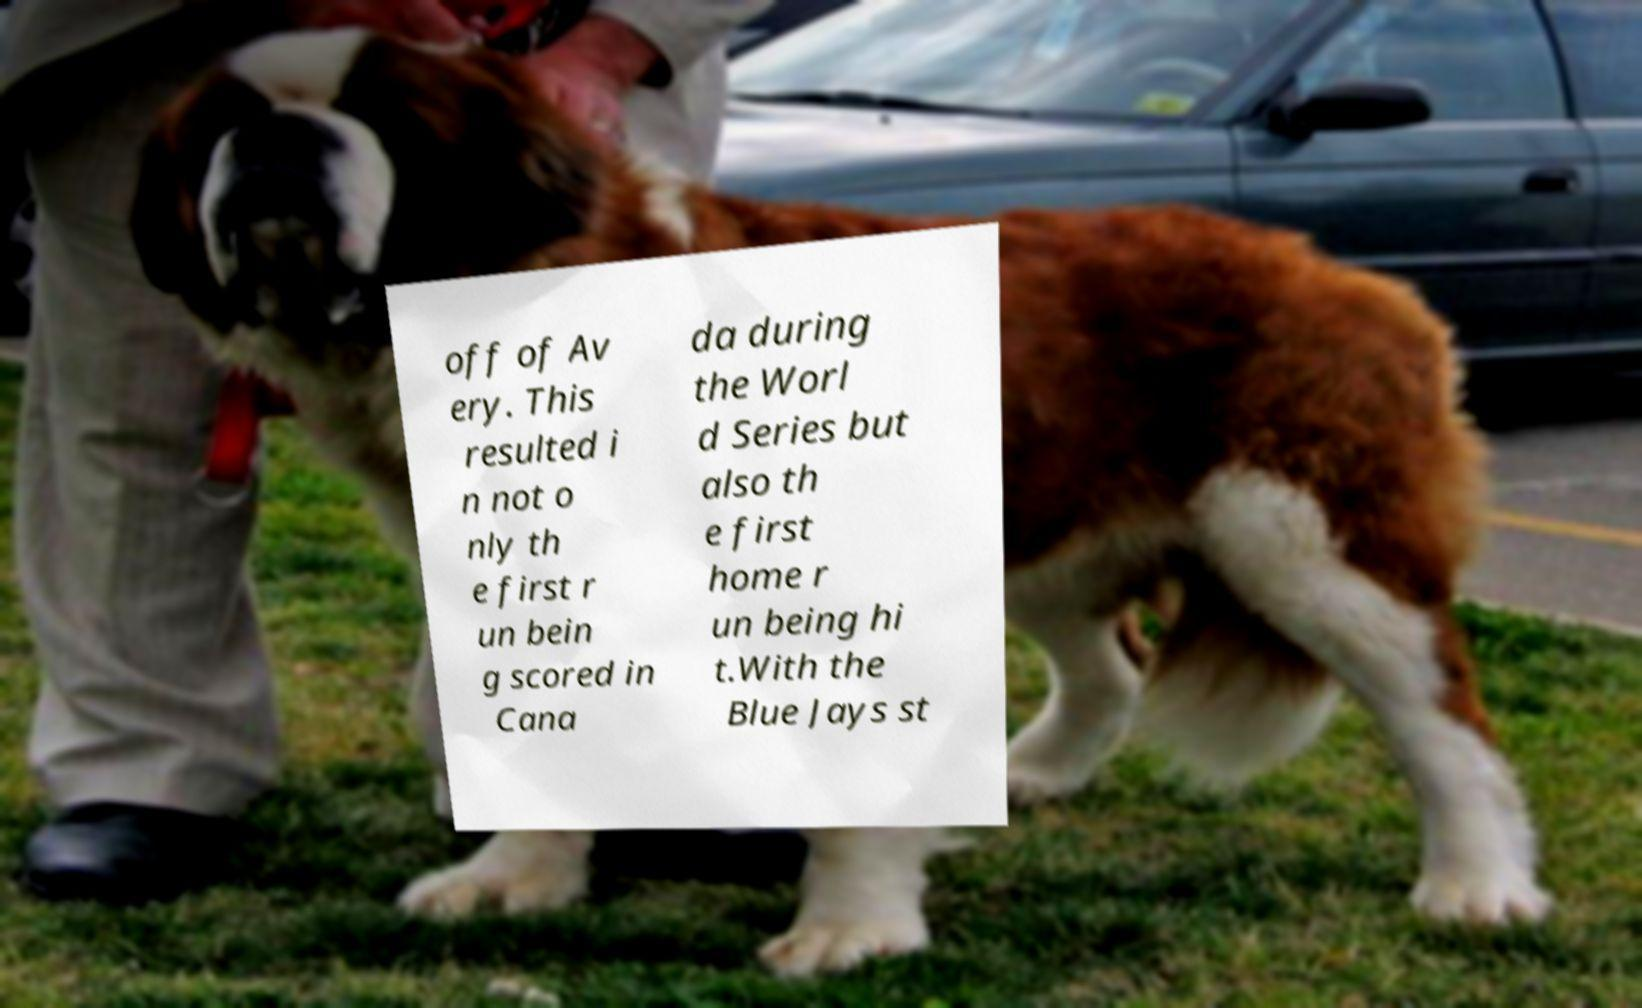For documentation purposes, I need the text within this image transcribed. Could you provide that? off of Av ery. This resulted i n not o nly th e first r un bein g scored in Cana da during the Worl d Series but also th e first home r un being hi t.With the Blue Jays st 